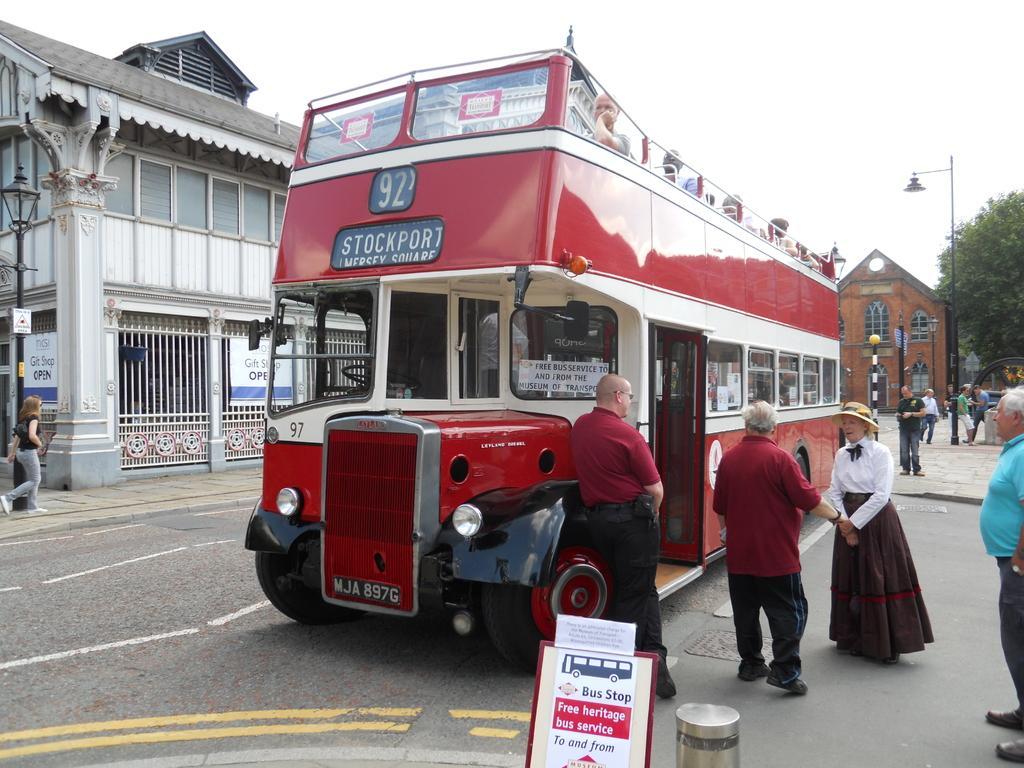Can you describe this image briefly? In this image there is a bus on a road and people are standing, on either side of the road there are footpaths and people are walking on the footpath, in the background there are houses, trees, light poles and the sky. 